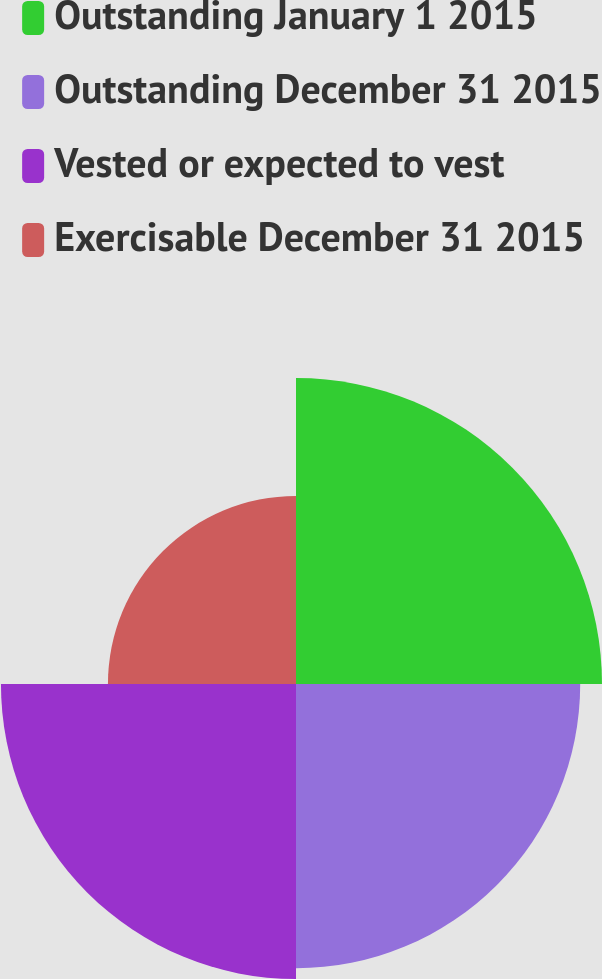<chart> <loc_0><loc_0><loc_500><loc_500><pie_chart><fcel>Outstanding January 1 2015<fcel>Outstanding December 31 2015<fcel>Vested or expected to vest<fcel>Exercisable December 31 2015<nl><fcel>28.51%<fcel>26.48%<fcel>27.49%<fcel>17.52%<nl></chart> 